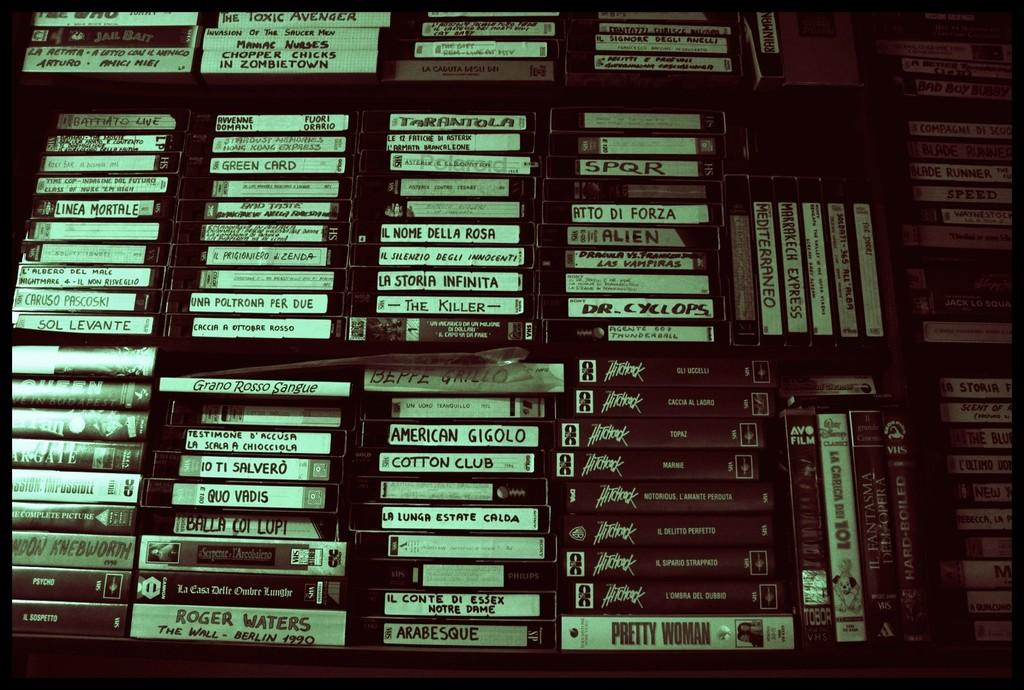Provide a one-sentence caption for the provided image. Stacks of VHS tapes such as Pretty Woman and Hitchcock line a wall up to the ceiling. 